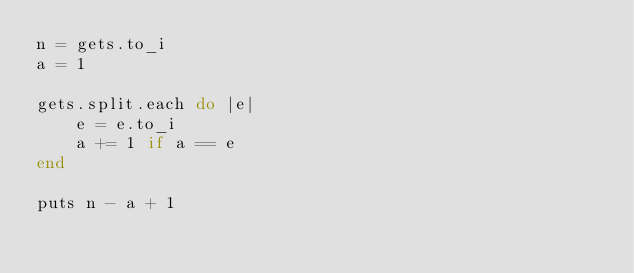Convert code to text. <code><loc_0><loc_0><loc_500><loc_500><_Ruby_>n = gets.to_i
a = 1

gets.split.each do |e|
    e = e.to_i
    a += 1 if a == e
end

puts n - a + 1</code> 